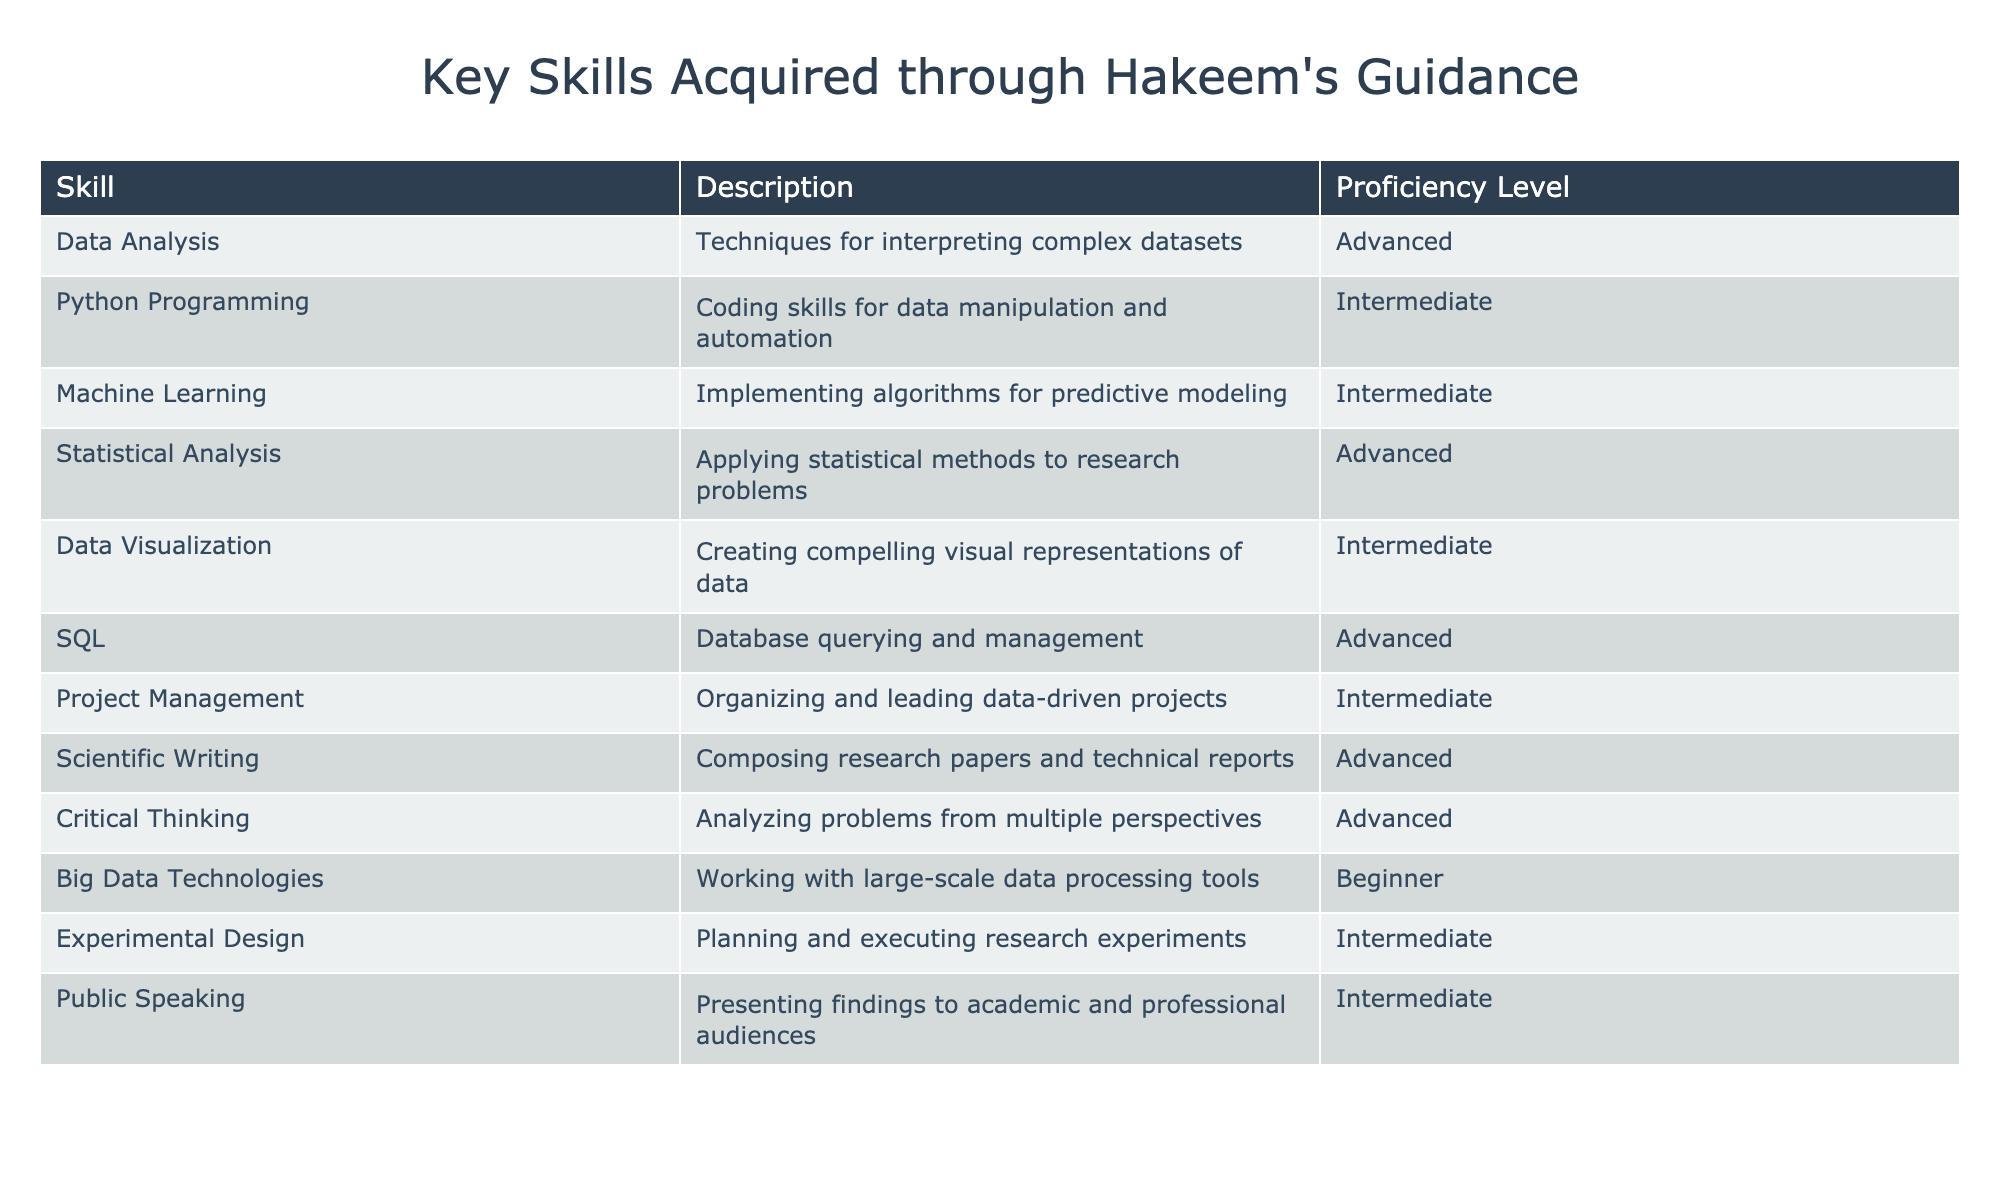What is the highest proficiency level skill listed in the table? The highest proficiency levels in the table are "Advanced". By checking each skill's proficiency level, we find multiple skills, such as Data Analysis and SQL, that have "Advanced" listed as their proficiency.
Answer: Advanced How many skills are listed at the "Intermediate" proficiency level? By counting the skills listed in the table, we see that there are 5 skills at the "Intermediate" proficiency level: Python Programming, Machine Learning, Data Visualization, Project Management, and Experimental Design.
Answer: 5 Is "Big Data Technologies" listed as an "Advanced" proficiency skill? Checking the proficiency level for "Big Data Technologies", we see it is categorized as "Beginner", which means the statement is false.
Answer: No Which skills have a proficiency level lower than "Advanced"? We can identify the skills with proficiency levels lower than "Advanced" by looking for "Intermediate" and "Beginner". The skills are Python Programming, Machine Learning, Data Visualization, Project Management, Experimental Design, and Big Data Technologies.
Answer: Python Programming, Machine Learning, Data Visualization, Project Management, Experimental Design, Big Data Technologies Calculate the total number of skills with "Advanced" proficiency. We list the skills with "Advanced" proficiency, which are Data Analysis, Statistical Analysis, SQL, Scientific Writing, and Critical Thinking. There are 5 skills total with "Advanced" proficiency.
Answer: 5 Are there more skills categorized as "Advanced" than those categorized as "Beginner"? We can see that "Advanced" has 5 skills (Data Analysis, Statistical Analysis, SQL, Scientific Writing, Critical Thinking) while "Beginner" only has 1 skill (Big Data Technologies). Therefore, there are more skills in the "Advanced" category.
Answer: Yes What percentage of the skills listed are classified as "Intermediate"? There are a total of 12 skills in the table. Out of these, 5 skills are classified as "Intermediate". To find the percentage, we calculate (5/12) * 100, which is approximately 41.67%.
Answer: 41.67% Identify the skills that are represented as "Advanced" and also involve quantitative techniques. The skills that can be seen as involving quantitative techniques and are marked "Advanced" are Data Analysis, Statistical Analysis, and Machine Learning. These skills require numerical analysis often.
Answer: Data Analysis, Statistical Analysis, Machine Learning Which is the only skill categorized as "Beginner"? By reviewing the table, the only skill listed with a "Beginner" proficiency is "Big Data Technologies." There are no other skills at that level.
Answer: Big Data Technologies 